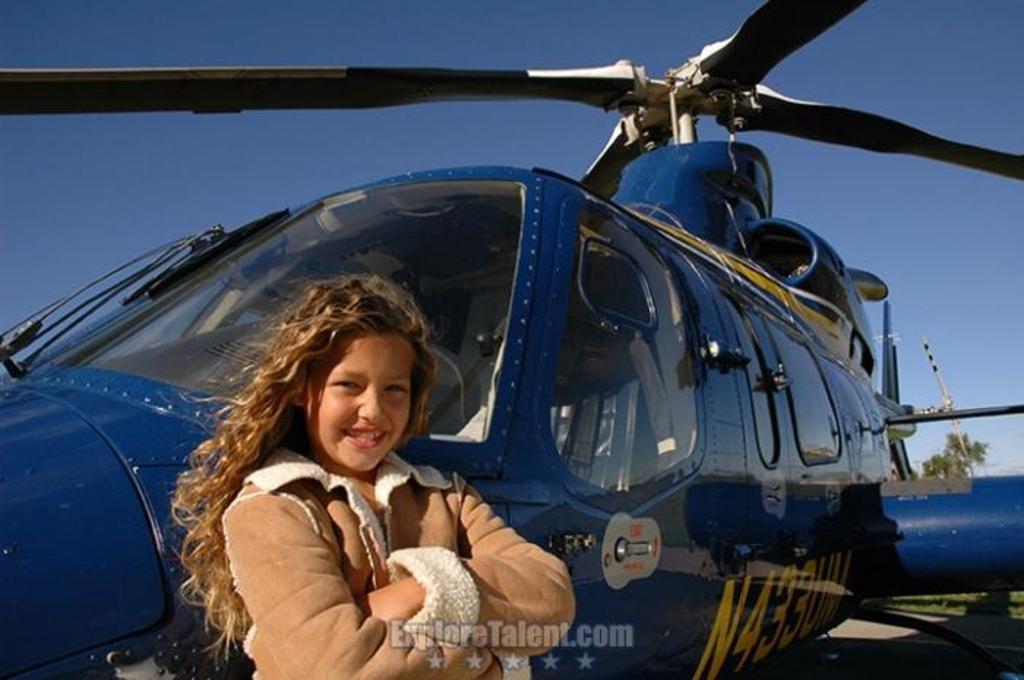What website is this photo from?
Your response must be concise. Exploretalent.com. What's the call number on the helicopter?
Provide a succinct answer. N433um. 